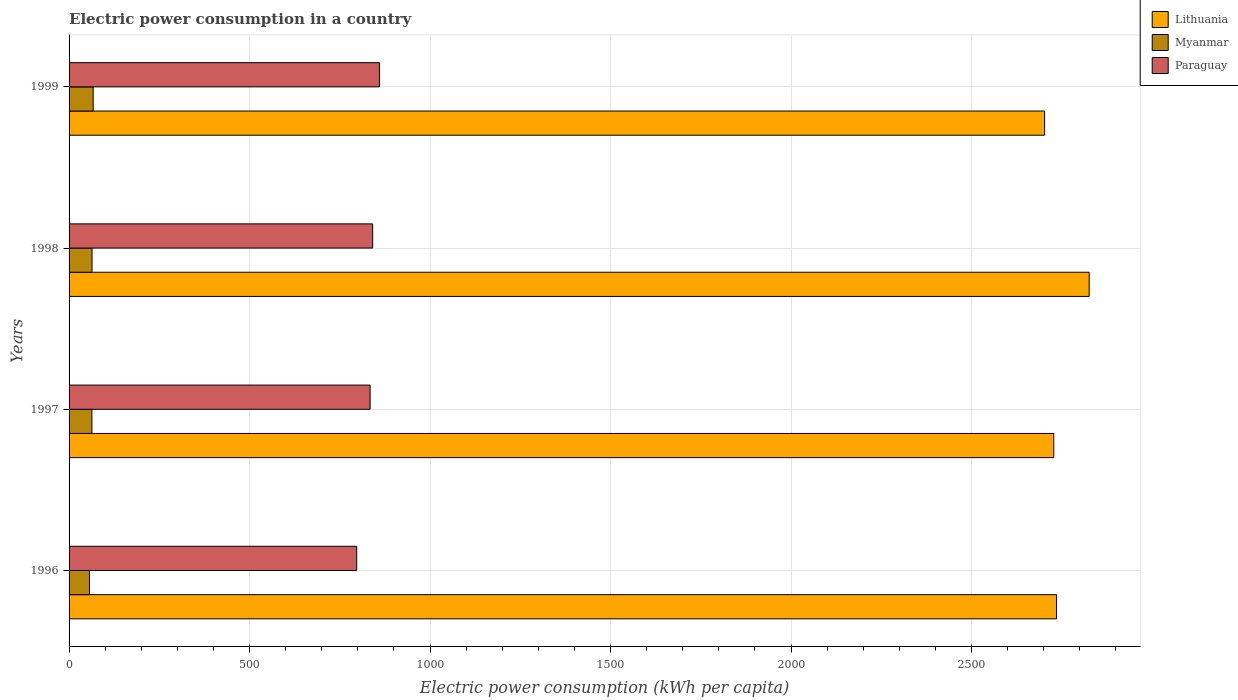How many groups of bars are there?
Offer a terse response. 4. Are the number of bars per tick equal to the number of legend labels?
Offer a terse response. Yes. How many bars are there on the 1st tick from the bottom?
Offer a very short reply. 3. In how many cases, is the number of bars for a given year not equal to the number of legend labels?
Give a very brief answer. 0. What is the electric power consumption in in Lithuania in 1998?
Offer a terse response. 2825.88. Across all years, what is the maximum electric power consumption in in Lithuania?
Offer a terse response. 2825.88. Across all years, what is the minimum electric power consumption in in Lithuania?
Provide a short and direct response. 2702.43. In which year was the electric power consumption in in Paraguay maximum?
Your answer should be compact. 1999. What is the total electric power consumption in in Lithuania in the graph?
Offer a terse response. 1.10e+04. What is the difference between the electric power consumption in in Lithuania in 1998 and that in 1999?
Give a very brief answer. 123.46. What is the difference between the electric power consumption in in Paraguay in 1996 and the electric power consumption in in Lithuania in 1999?
Ensure brevity in your answer.  -1905.62. What is the average electric power consumption in in Paraguay per year?
Your answer should be very brief. 832.85. In the year 1998, what is the difference between the electric power consumption in in Myanmar and electric power consumption in in Paraguay?
Your answer should be very brief. -777.36. What is the ratio of the electric power consumption in in Myanmar in 1996 to that in 1998?
Offer a very short reply. 0.89. What is the difference between the highest and the second highest electric power consumption in in Paraguay?
Your answer should be very brief. 18.76. What is the difference between the highest and the lowest electric power consumption in in Paraguay?
Your answer should be compact. 62.93. In how many years, is the electric power consumption in in Myanmar greater than the average electric power consumption in in Myanmar taken over all years?
Offer a very short reply. 3. Is the sum of the electric power consumption in in Myanmar in 1996 and 1997 greater than the maximum electric power consumption in in Lithuania across all years?
Provide a short and direct response. No. What does the 3rd bar from the top in 1999 represents?
Ensure brevity in your answer.  Lithuania. What does the 2nd bar from the bottom in 1998 represents?
Your answer should be very brief. Myanmar. How many bars are there?
Provide a short and direct response. 12. Are all the bars in the graph horizontal?
Provide a succinct answer. Yes. What is the difference between two consecutive major ticks on the X-axis?
Provide a short and direct response. 500. Are the values on the major ticks of X-axis written in scientific E-notation?
Provide a short and direct response. No. How many legend labels are there?
Offer a terse response. 3. How are the legend labels stacked?
Give a very brief answer. Vertical. What is the title of the graph?
Keep it short and to the point. Electric power consumption in a country. Does "Congo (Democratic)" appear as one of the legend labels in the graph?
Offer a terse response. No. What is the label or title of the X-axis?
Your response must be concise. Electric power consumption (kWh per capita). What is the label or title of the Y-axis?
Your answer should be compact. Years. What is the Electric power consumption (kWh per capita) of Lithuania in 1996?
Your response must be concise. 2735.44. What is the Electric power consumption (kWh per capita) in Myanmar in 1996?
Make the answer very short. 56.57. What is the Electric power consumption (kWh per capita) of Paraguay in 1996?
Make the answer very short. 796.81. What is the Electric power consumption (kWh per capita) in Lithuania in 1997?
Offer a very short reply. 2727.73. What is the Electric power consumption (kWh per capita) of Myanmar in 1997?
Your answer should be compact. 63.25. What is the Electric power consumption (kWh per capita) of Paraguay in 1997?
Keep it short and to the point. 833.88. What is the Electric power consumption (kWh per capita) of Lithuania in 1998?
Provide a short and direct response. 2825.88. What is the Electric power consumption (kWh per capita) in Myanmar in 1998?
Ensure brevity in your answer.  63.62. What is the Electric power consumption (kWh per capita) in Paraguay in 1998?
Give a very brief answer. 840.98. What is the Electric power consumption (kWh per capita) of Lithuania in 1999?
Keep it short and to the point. 2702.43. What is the Electric power consumption (kWh per capita) of Myanmar in 1999?
Offer a very short reply. 66.76. What is the Electric power consumption (kWh per capita) in Paraguay in 1999?
Offer a very short reply. 859.74. Across all years, what is the maximum Electric power consumption (kWh per capita) of Lithuania?
Offer a terse response. 2825.88. Across all years, what is the maximum Electric power consumption (kWh per capita) in Myanmar?
Provide a short and direct response. 66.76. Across all years, what is the maximum Electric power consumption (kWh per capita) of Paraguay?
Offer a terse response. 859.74. Across all years, what is the minimum Electric power consumption (kWh per capita) in Lithuania?
Give a very brief answer. 2702.43. Across all years, what is the minimum Electric power consumption (kWh per capita) of Myanmar?
Your response must be concise. 56.57. Across all years, what is the minimum Electric power consumption (kWh per capita) of Paraguay?
Provide a succinct answer. 796.81. What is the total Electric power consumption (kWh per capita) in Lithuania in the graph?
Your answer should be compact. 1.10e+04. What is the total Electric power consumption (kWh per capita) of Myanmar in the graph?
Your answer should be compact. 250.2. What is the total Electric power consumption (kWh per capita) in Paraguay in the graph?
Your answer should be compact. 3331.4. What is the difference between the Electric power consumption (kWh per capita) in Lithuania in 1996 and that in 1997?
Your response must be concise. 7.71. What is the difference between the Electric power consumption (kWh per capita) in Myanmar in 1996 and that in 1997?
Your answer should be compact. -6.68. What is the difference between the Electric power consumption (kWh per capita) of Paraguay in 1996 and that in 1997?
Give a very brief answer. -37.07. What is the difference between the Electric power consumption (kWh per capita) in Lithuania in 1996 and that in 1998?
Your answer should be very brief. -90.44. What is the difference between the Electric power consumption (kWh per capita) of Myanmar in 1996 and that in 1998?
Provide a short and direct response. -7.05. What is the difference between the Electric power consumption (kWh per capita) in Paraguay in 1996 and that in 1998?
Provide a succinct answer. -44.17. What is the difference between the Electric power consumption (kWh per capita) in Lithuania in 1996 and that in 1999?
Your answer should be compact. 33.01. What is the difference between the Electric power consumption (kWh per capita) in Myanmar in 1996 and that in 1999?
Your answer should be compact. -10.2. What is the difference between the Electric power consumption (kWh per capita) in Paraguay in 1996 and that in 1999?
Ensure brevity in your answer.  -62.93. What is the difference between the Electric power consumption (kWh per capita) in Lithuania in 1997 and that in 1998?
Make the answer very short. -98.16. What is the difference between the Electric power consumption (kWh per capita) of Myanmar in 1997 and that in 1998?
Provide a succinct answer. -0.37. What is the difference between the Electric power consumption (kWh per capita) of Paraguay in 1997 and that in 1998?
Provide a succinct answer. -7.1. What is the difference between the Electric power consumption (kWh per capita) of Lithuania in 1997 and that in 1999?
Provide a short and direct response. 25.3. What is the difference between the Electric power consumption (kWh per capita) of Myanmar in 1997 and that in 1999?
Offer a very short reply. -3.51. What is the difference between the Electric power consumption (kWh per capita) of Paraguay in 1997 and that in 1999?
Give a very brief answer. -25.86. What is the difference between the Electric power consumption (kWh per capita) of Lithuania in 1998 and that in 1999?
Keep it short and to the point. 123.46. What is the difference between the Electric power consumption (kWh per capita) in Myanmar in 1998 and that in 1999?
Keep it short and to the point. -3.14. What is the difference between the Electric power consumption (kWh per capita) in Paraguay in 1998 and that in 1999?
Keep it short and to the point. -18.76. What is the difference between the Electric power consumption (kWh per capita) of Lithuania in 1996 and the Electric power consumption (kWh per capita) of Myanmar in 1997?
Give a very brief answer. 2672.19. What is the difference between the Electric power consumption (kWh per capita) in Lithuania in 1996 and the Electric power consumption (kWh per capita) in Paraguay in 1997?
Provide a succinct answer. 1901.56. What is the difference between the Electric power consumption (kWh per capita) of Myanmar in 1996 and the Electric power consumption (kWh per capita) of Paraguay in 1997?
Keep it short and to the point. -777.31. What is the difference between the Electric power consumption (kWh per capita) of Lithuania in 1996 and the Electric power consumption (kWh per capita) of Myanmar in 1998?
Ensure brevity in your answer.  2671.82. What is the difference between the Electric power consumption (kWh per capita) in Lithuania in 1996 and the Electric power consumption (kWh per capita) in Paraguay in 1998?
Ensure brevity in your answer.  1894.46. What is the difference between the Electric power consumption (kWh per capita) in Myanmar in 1996 and the Electric power consumption (kWh per capita) in Paraguay in 1998?
Provide a short and direct response. -784.41. What is the difference between the Electric power consumption (kWh per capita) in Lithuania in 1996 and the Electric power consumption (kWh per capita) in Myanmar in 1999?
Keep it short and to the point. 2668.68. What is the difference between the Electric power consumption (kWh per capita) of Lithuania in 1996 and the Electric power consumption (kWh per capita) of Paraguay in 1999?
Provide a succinct answer. 1875.7. What is the difference between the Electric power consumption (kWh per capita) of Myanmar in 1996 and the Electric power consumption (kWh per capita) of Paraguay in 1999?
Your answer should be compact. -803.17. What is the difference between the Electric power consumption (kWh per capita) in Lithuania in 1997 and the Electric power consumption (kWh per capita) in Myanmar in 1998?
Give a very brief answer. 2664.11. What is the difference between the Electric power consumption (kWh per capita) in Lithuania in 1997 and the Electric power consumption (kWh per capita) in Paraguay in 1998?
Offer a very short reply. 1886.75. What is the difference between the Electric power consumption (kWh per capita) of Myanmar in 1997 and the Electric power consumption (kWh per capita) of Paraguay in 1998?
Offer a terse response. -777.73. What is the difference between the Electric power consumption (kWh per capita) of Lithuania in 1997 and the Electric power consumption (kWh per capita) of Myanmar in 1999?
Offer a terse response. 2660.96. What is the difference between the Electric power consumption (kWh per capita) in Lithuania in 1997 and the Electric power consumption (kWh per capita) in Paraguay in 1999?
Your answer should be very brief. 1867.99. What is the difference between the Electric power consumption (kWh per capita) in Myanmar in 1997 and the Electric power consumption (kWh per capita) in Paraguay in 1999?
Make the answer very short. -796.49. What is the difference between the Electric power consumption (kWh per capita) of Lithuania in 1998 and the Electric power consumption (kWh per capita) of Myanmar in 1999?
Offer a very short reply. 2759.12. What is the difference between the Electric power consumption (kWh per capita) of Lithuania in 1998 and the Electric power consumption (kWh per capita) of Paraguay in 1999?
Your response must be concise. 1966.15. What is the difference between the Electric power consumption (kWh per capita) of Myanmar in 1998 and the Electric power consumption (kWh per capita) of Paraguay in 1999?
Give a very brief answer. -796.12. What is the average Electric power consumption (kWh per capita) of Lithuania per year?
Your response must be concise. 2747.87. What is the average Electric power consumption (kWh per capita) of Myanmar per year?
Ensure brevity in your answer.  62.55. What is the average Electric power consumption (kWh per capita) in Paraguay per year?
Ensure brevity in your answer.  832.85. In the year 1996, what is the difference between the Electric power consumption (kWh per capita) of Lithuania and Electric power consumption (kWh per capita) of Myanmar?
Keep it short and to the point. 2678.87. In the year 1996, what is the difference between the Electric power consumption (kWh per capita) in Lithuania and Electric power consumption (kWh per capita) in Paraguay?
Keep it short and to the point. 1938.63. In the year 1996, what is the difference between the Electric power consumption (kWh per capita) in Myanmar and Electric power consumption (kWh per capita) in Paraguay?
Ensure brevity in your answer.  -740.24. In the year 1997, what is the difference between the Electric power consumption (kWh per capita) of Lithuania and Electric power consumption (kWh per capita) of Myanmar?
Ensure brevity in your answer.  2664.48. In the year 1997, what is the difference between the Electric power consumption (kWh per capita) of Lithuania and Electric power consumption (kWh per capita) of Paraguay?
Your answer should be very brief. 1893.85. In the year 1997, what is the difference between the Electric power consumption (kWh per capita) of Myanmar and Electric power consumption (kWh per capita) of Paraguay?
Make the answer very short. -770.63. In the year 1998, what is the difference between the Electric power consumption (kWh per capita) in Lithuania and Electric power consumption (kWh per capita) in Myanmar?
Provide a short and direct response. 2762.26. In the year 1998, what is the difference between the Electric power consumption (kWh per capita) in Lithuania and Electric power consumption (kWh per capita) in Paraguay?
Offer a very short reply. 1984.91. In the year 1998, what is the difference between the Electric power consumption (kWh per capita) in Myanmar and Electric power consumption (kWh per capita) in Paraguay?
Give a very brief answer. -777.36. In the year 1999, what is the difference between the Electric power consumption (kWh per capita) in Lithuania and Electric power consumption (kWh per capita) in Myanmar?
Your answer should be very brief. 2635.67. In the year 1999, what is the difference between the Electric power consumption (kWh per capita) of Lithuania and Electric power consumption (kWh per capita) of Paraguay?
Make the answer very short. 1842.69. In the year 1999, what is the difference between the Electric power consumption (kWh per capita) of Myanmar and Electric power consumption (kWh per capita) of Paraguay?
Give a very brief answer. -792.97. What is the ratio of the Electric power consumption (kWh per capita) of Lithuania in 1996 to that in 1997?
Provide a short and direct response. 1. What is the ratio of the Electric power consumption (kWh per capita) of Myanmar in 1996 to that in 1997?
Provide a short and direct response. 0.89. What is the ratio of the Electric power consumption (kWh per capita) in Paraguay in 1996 to that in 1997?
Offer a terse response. 0.96. What is the ratio of the Electric power consumption (kWh per capita) of Lithuania in 1996 to that in 1998?
Ensure brevity in your answer.  0.97. What is the ratio of the Electric power consumption (kWh per capita) in Myanmar in 1996 to that in 1998?
Your answer should be very brief. 0.89. What is the ratio of the Electric power consumption (kWh per capita) in Paraguay in 1996 to that in 1998?
Provide a succinct answer. 0.95. What is the ratio of the Electric power consumption (kWh per capita) in Lithuania in 1996 to that in 1999?
Ensure brevity in your answer.  1.01. What is the ratio of the Electric power consumption (kWh per capita) of Myanmar in 1996 to that in 1999?
Make the answer very short. 0.85. What is the ratio of the Electric power consumption (kWh per capita) in Paraguay in 1996 to that in 1999?
Provide a succinct answer. 0.93. What is the ratio of the Electric power consumption (kWh per capita) of Lithuania in 1997 to that in 1998?
Keep it short and to the point. 0.97. What is the ratio of the Electric power consumption (kWh per capita) in Lithuania in 1997 to that in 1999?
Provide a succinct answer. 1.01. What is the ratio of the Electric power consumption (kWh per capita) in Myanmar in 1997 to that in 1999?
Make the answer very short. 0.95. What is the ratio of the Electric power consumption (kWh per capita) in Paraguay in 1997 to that in 1999?
Your response must be concise. 0.97. What is the ratio of the Electric power consumption (kWh per capita) of Lithuania in 1998 to that in 1999?
Provide a short and direct response. 1.05. What is the ratio of the Electric power consumption (kWh per capita) in Myanmar in 1998 to that in 1999?
Provide a succinct answer. 0.95. What is the ratio of the Electric power consumption (kWh per capita) in Paraguay in 1998 to that in 1999?
Your response must be concise. 0.98. What is the difference between the highest and the second highest Electric power consumption (kWh per capita) in Lithuania?
Ensure brevity in your answer.  90.44. What is the difference between the highest and the second highest Electric power consumption (kWh per capita) in Myanmar?
Keep it short and to the point. 3.14. What is the difference between the highest and the second highest Electric power consumption (kWh per capita) in Paraguay?
Provide a succinct answer. 18.76. What is the difference between the highest and the lowest Electric power consumption (kWh per capita) in Lithuania?
Offer a very short reply. 123.46. What is the difference between the highest and the lowest Electric power consumption (kWh per capita) in Myanmar?
Give a very brief answer. 10.2. What is the difference between the highest and the lowest Electric power consumption (kWh per capita) in Paraguay?
Your answer should be very brief. 62.93. 